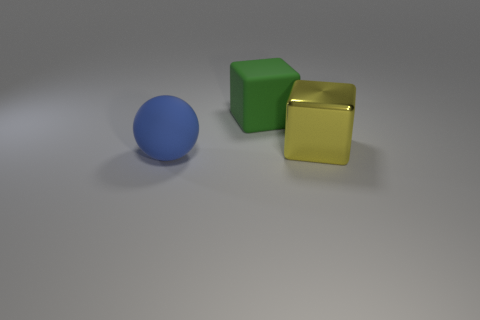What is the shape of the big thing that is on the right side of the large matte ball and left of the yellow thing? The object you're referring to is a cube. It's a geometric solid with six square faces of equal size that intersect at ninety degrees, creating a regular and symmetrical three-dimensional shape. This particular cube appears to have a green color and a matte surface, contrasting with the other objects in terms of color and shape. 